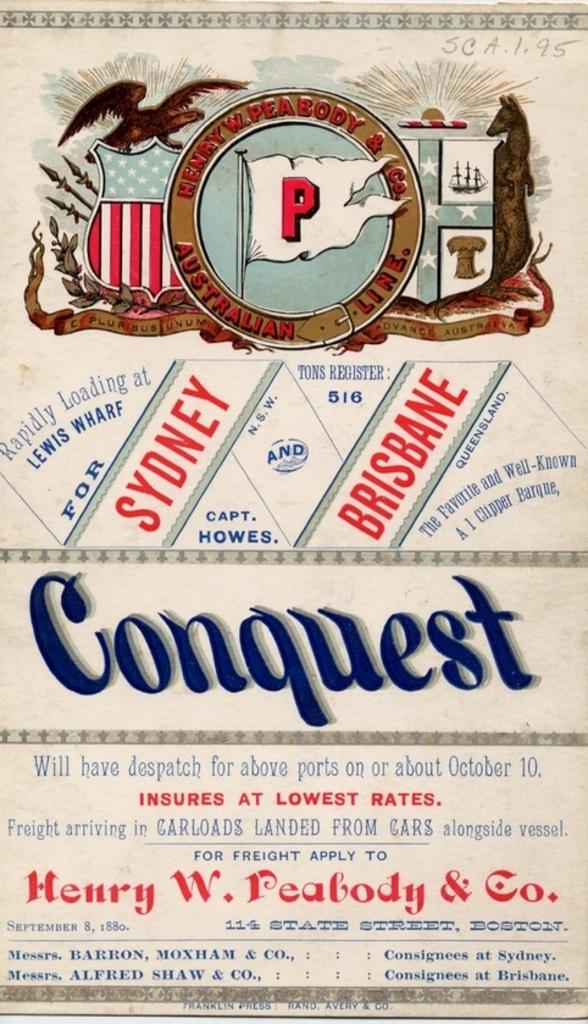<image>
Write a terse but informative summary of the picture. An old advertisement for a shipping company that goes to Sydney and Brisbane. 